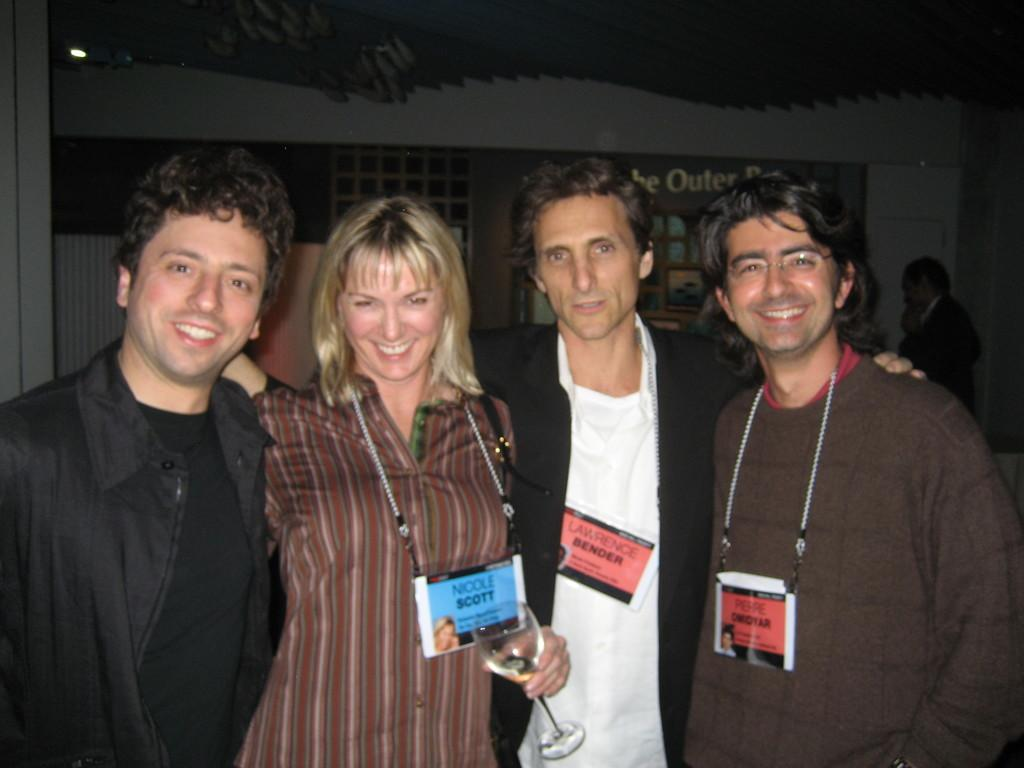How many people are in the image? There are four persons standing and smiling in the image. What is the woman holding in the image? The woman is holding a wine glass. Can you describe the background of the image? In the background, there is a person standing, and there are some objects visible. What type of story is the baby telling in the image? There is no baby present in the image, so it is not possible to answer that question. 